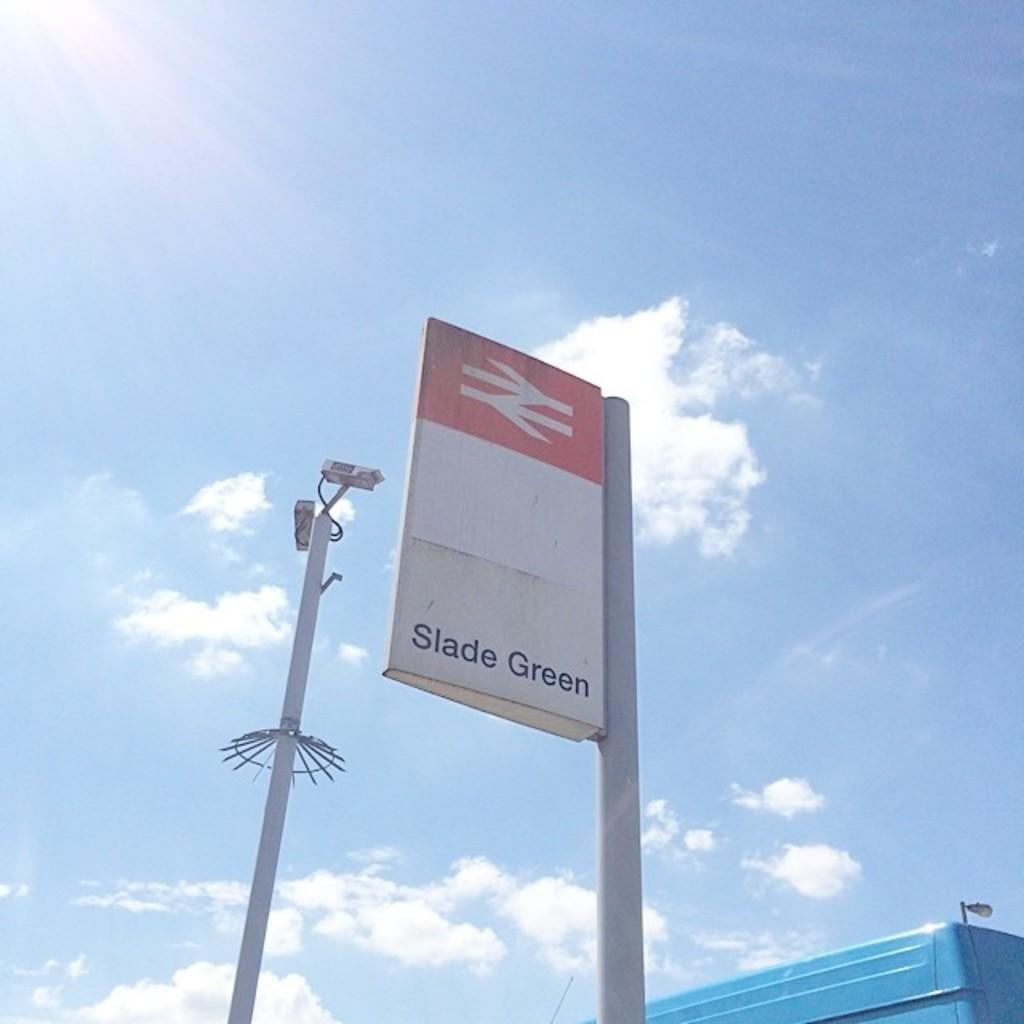<image>
Share a concise interpretation of the image provided. A sign post on a sunny day reads "Slade Green." 